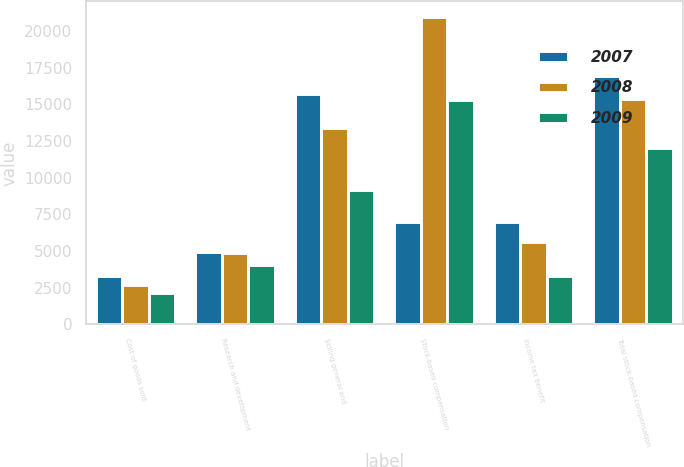Convert chart. <chart><loc_0><loc_0><loc_500><loc_500><stacked_bar_chart><ecel><fcel>Cost of goods sold<fcel>Research and development<fcel>Selling general and<fcel>Stock-based compensation<fcel>Income tax benefit<fcel>Total stock-based compensation<nl><fcel>2007<fcel>3297<fcel>4943<fcel>15715<fcel>7011<fcel>7011<fcel>16944<nl><fcel>2008<fcel>2721<fcel>4882<fcel>13371<fcel>20974<fcel>5589<fcel>15385<nl><fcel>2009<fcel>2124<fcel>4033<fcel>9159<fcel>15316<fcel>3286<fcel>12030<nl></chart> 